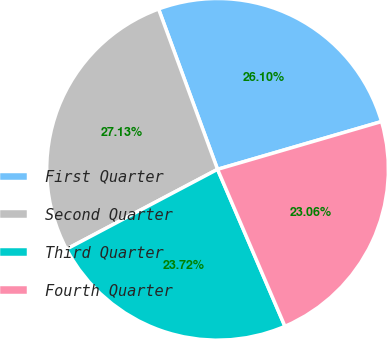Convert chart. <chart><loc_0><loc_0><loc_500><loc_500><pie_chart><fcel>First Quarter<fcel>Second Quarter<fcel>Third Quarter<fcel>Fourth Quarter<nl><fcel>26.1%<fcel>27.13%<fcel>23.72%<fcel>23.06%<nl></chart> 